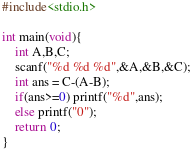Convert code to text. <code><loc_0><loc_0><loc_500><loc_500><_C_>#include<stdio.h>

int main(void){
    int A,B,C;
    scanf("%d %d %d",&A,&B,&C);
    int ans = C-(A-B);
    if(ans>=0) printf("%d",ans);
    else printf("0");
    return 0;
}</code> 